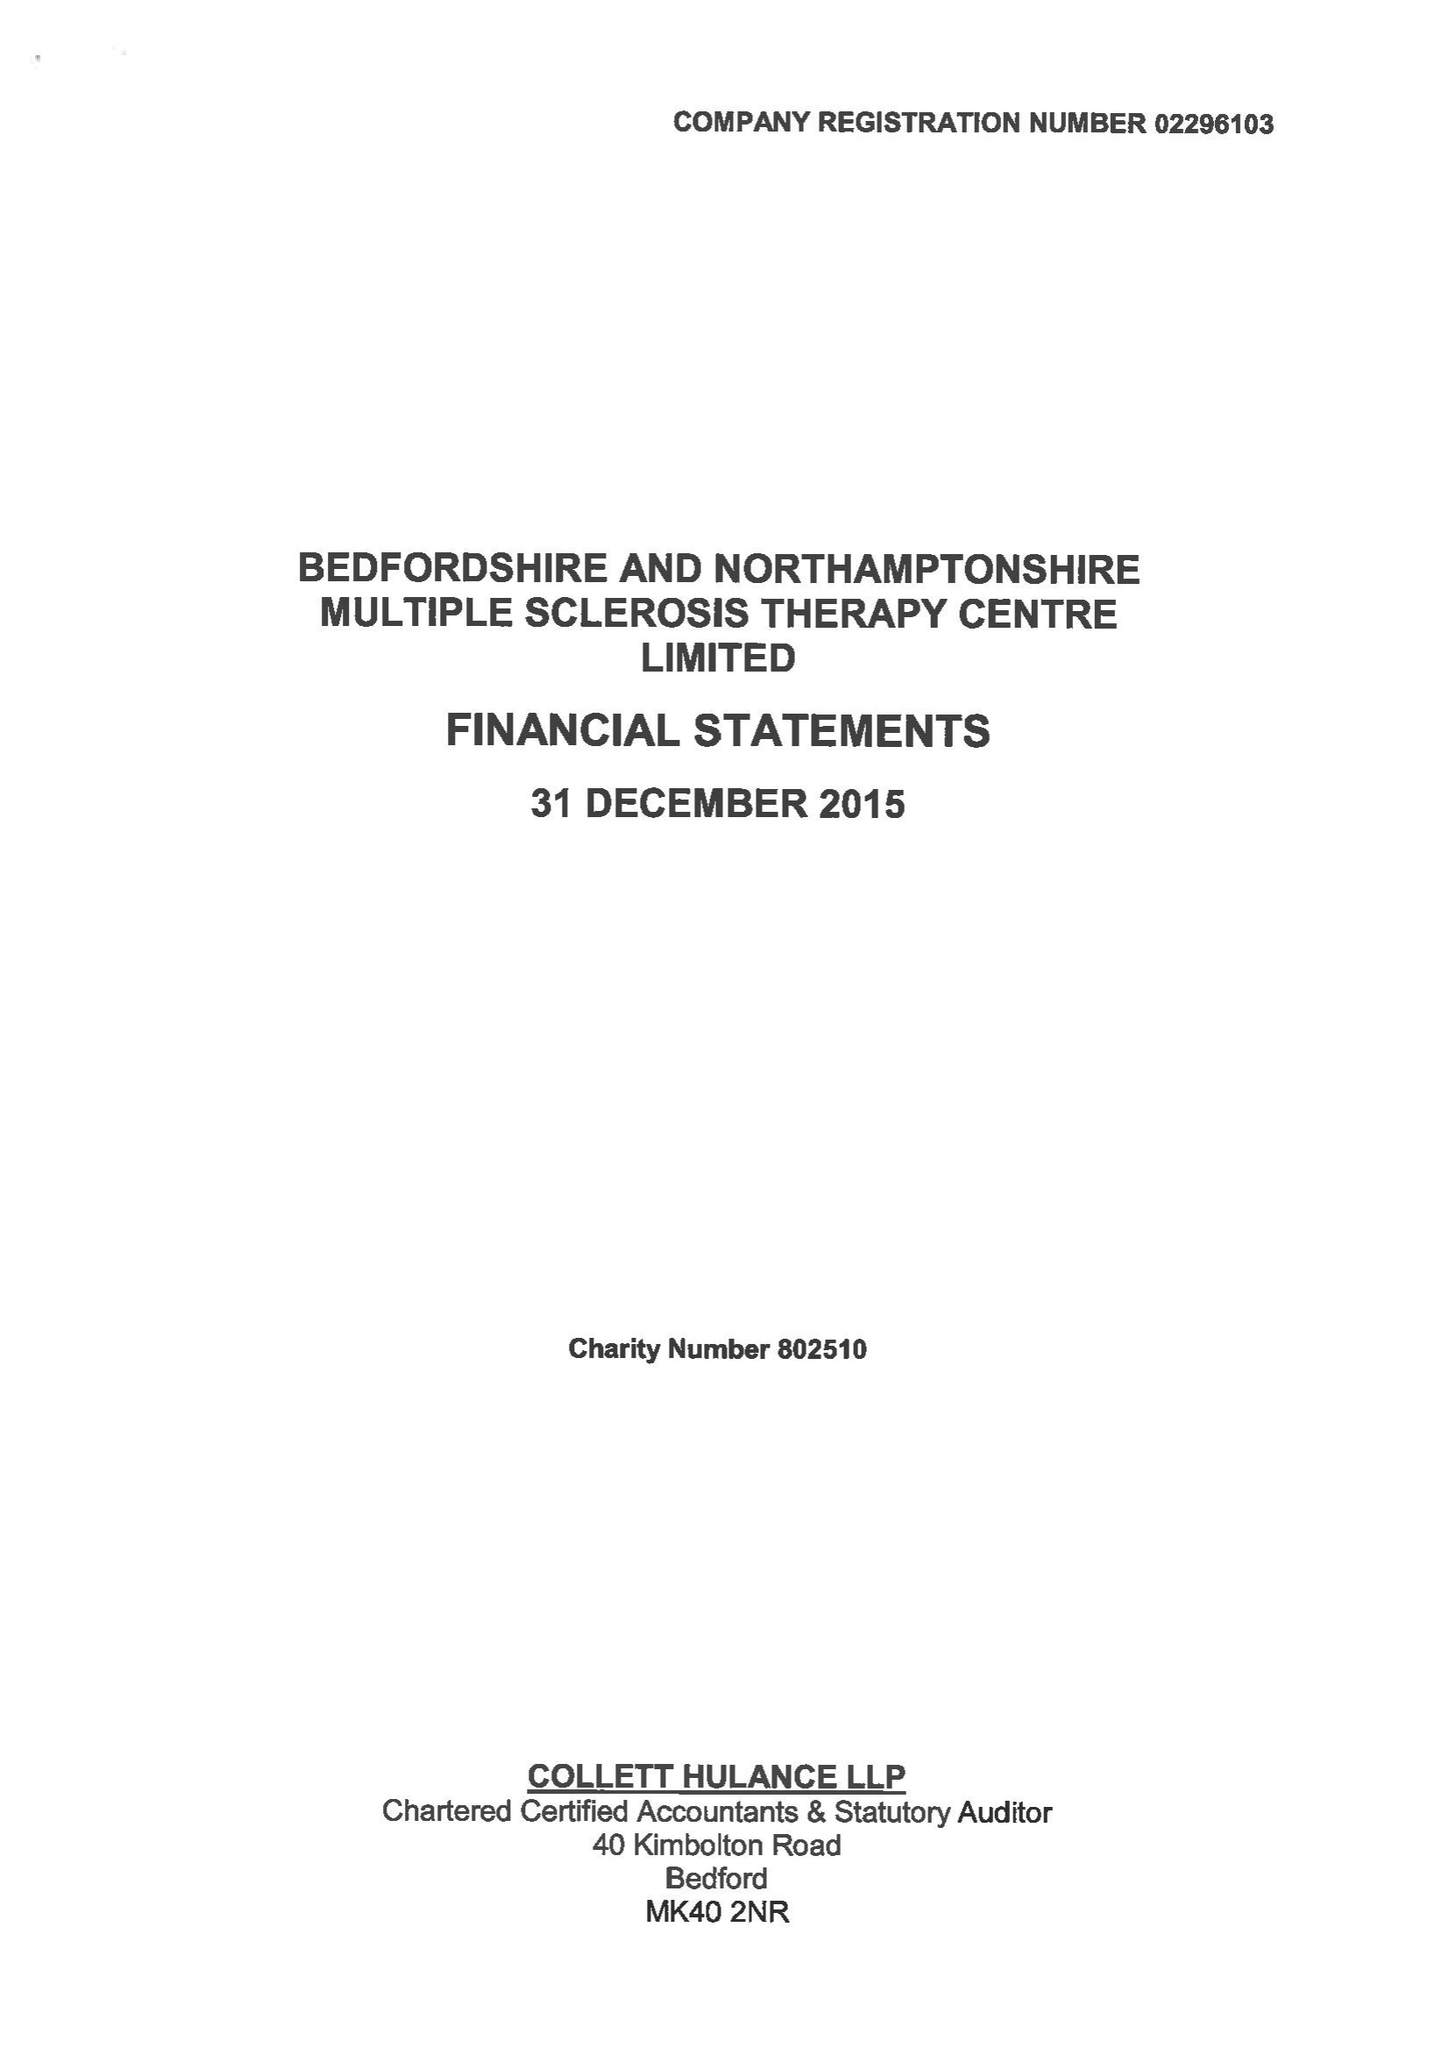What is the value for the charity_number?
Answer the question using a single word or phrase. 802510 